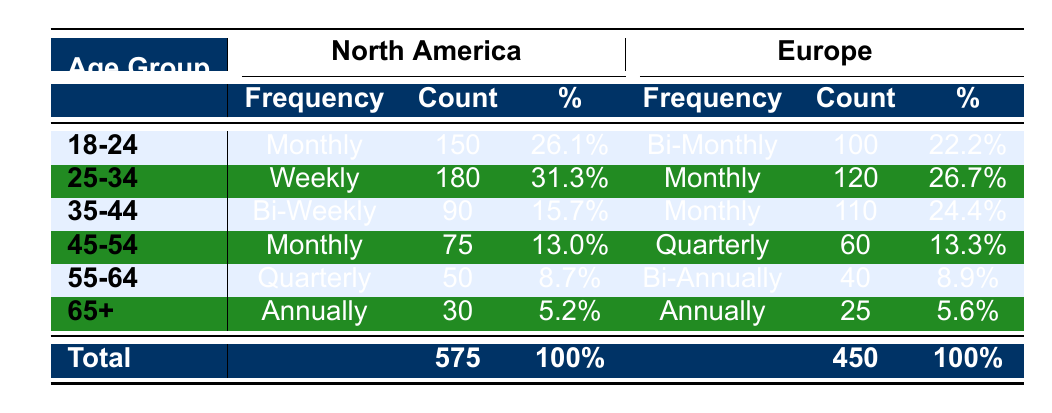What is the purchase frequency for the age group 25-34 in North America? The table shows the purchase frequency for the age group 25-34 in North America as Weekly.
Answer: Weekly How many customers aged 45-54 in Europe make purchases quarterly? The table lists the frequency for customers aged 45-54 in Europe as Quarterly, with a count of 60.
Answer: 60 Which age group in North America has the highest purchase frequency count? Comparing the counts for each age group in North America, 180 from the 25-34 age group (Weekly) is the highest, followed by 150 from the 18-24 age group (Monthly).
Answer: 25-34 What percentage of customers aged 18-24 in Europe make purchases bi-monthly? The table indicates that out of the total customers in that age group, 100 make bi-monthly purchases, which constitutes 22.2%.
Answer: 22.2% Is it true that customers aged 65+ in North America have a higher purchase frequency than those in Europe? Yes, both age groups have an annual frequency, but North America has a count of 30 while Europe has 25. So, North America has a higher count.
Answer: Yes What is the total purchase frequency count for customers aged 35-44 across both regions? The count for North America is 90 (Bi-Weekly), and for Europe it is 110 (Monthly), summing these gives a total of 200.
Answer: 200 Which age group in Europe spends the least on purchase frequency? By reviewing the counts, the age group 55-64 spends the least in Europe with a purchase frequency count of 40 (Bi-Annually).
Answer: 55-64 What is the average purchase frequency count for customers aged 55-64 across both regions? In North America, the count is 50 (Quarterly) and in Europe, it's 40 (Bi-Annually), the average is (50 + 40) / 2 = 45.
Answer: 45 How does the purchase frequency of 35-44 year-olds in North America compare to that of the same age group in Europe? North America has a count of 90 (Bi-Weekly) while Europe has 110 (Monthly), making Europe higher by 20.
Answer: Europe is higher by 20 